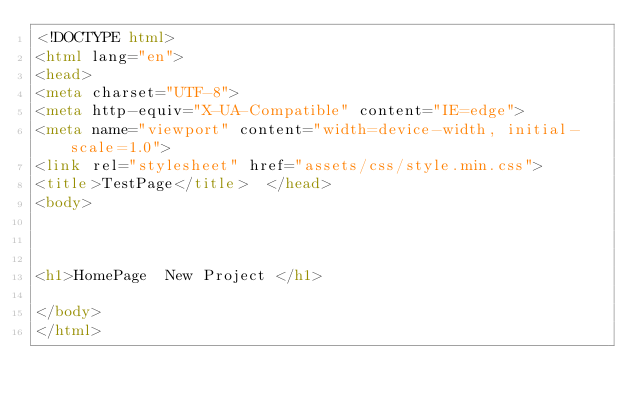Convert code to text. <code><loc_0><loc_0><loc_500><loc_500><_HTML_><!DOCTYPE html>
<html lang="en">
<head>
<meta charset="UTF-8">
<meta http-equiv="X-UA-Compatible" content="IE=edge">
<meta name="viewport" content="width=device-width, initial-scale=1.0">
<link rel="stylesheet" href="assets/css/style.min.css">
<title>TestPage</title>  </head>
<body>
    


<h1>HomePage  New Project </h1>

</body>
</html></code> 